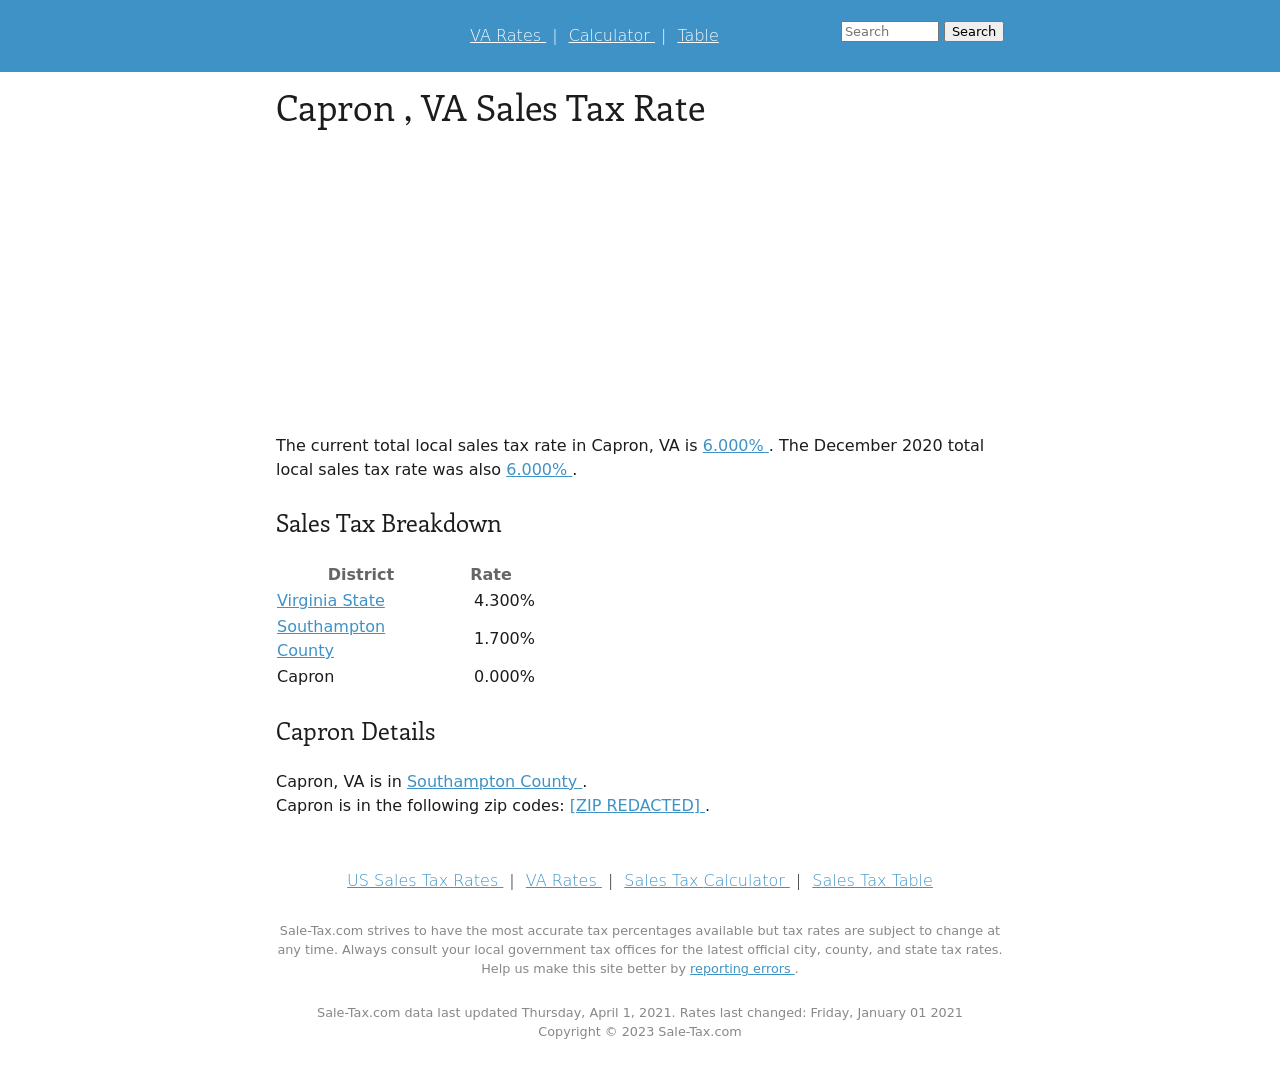Can you explain more about why the sales tax rate in Capron, VA, is structured as it is? Certainly! The sales tax in Capron, VA is comprised of several components: the Virginia State tax, Southampton County tax, and the local Capron tax. These rates are cumulative, leading to the total tax rate. The state tax provides revenue for state-wide services, while county and local taxes fund regional and municipal services. Capron itself has a 0.000% tax, indicating it doesn't add additional local taxes on top of the county and state rates. 